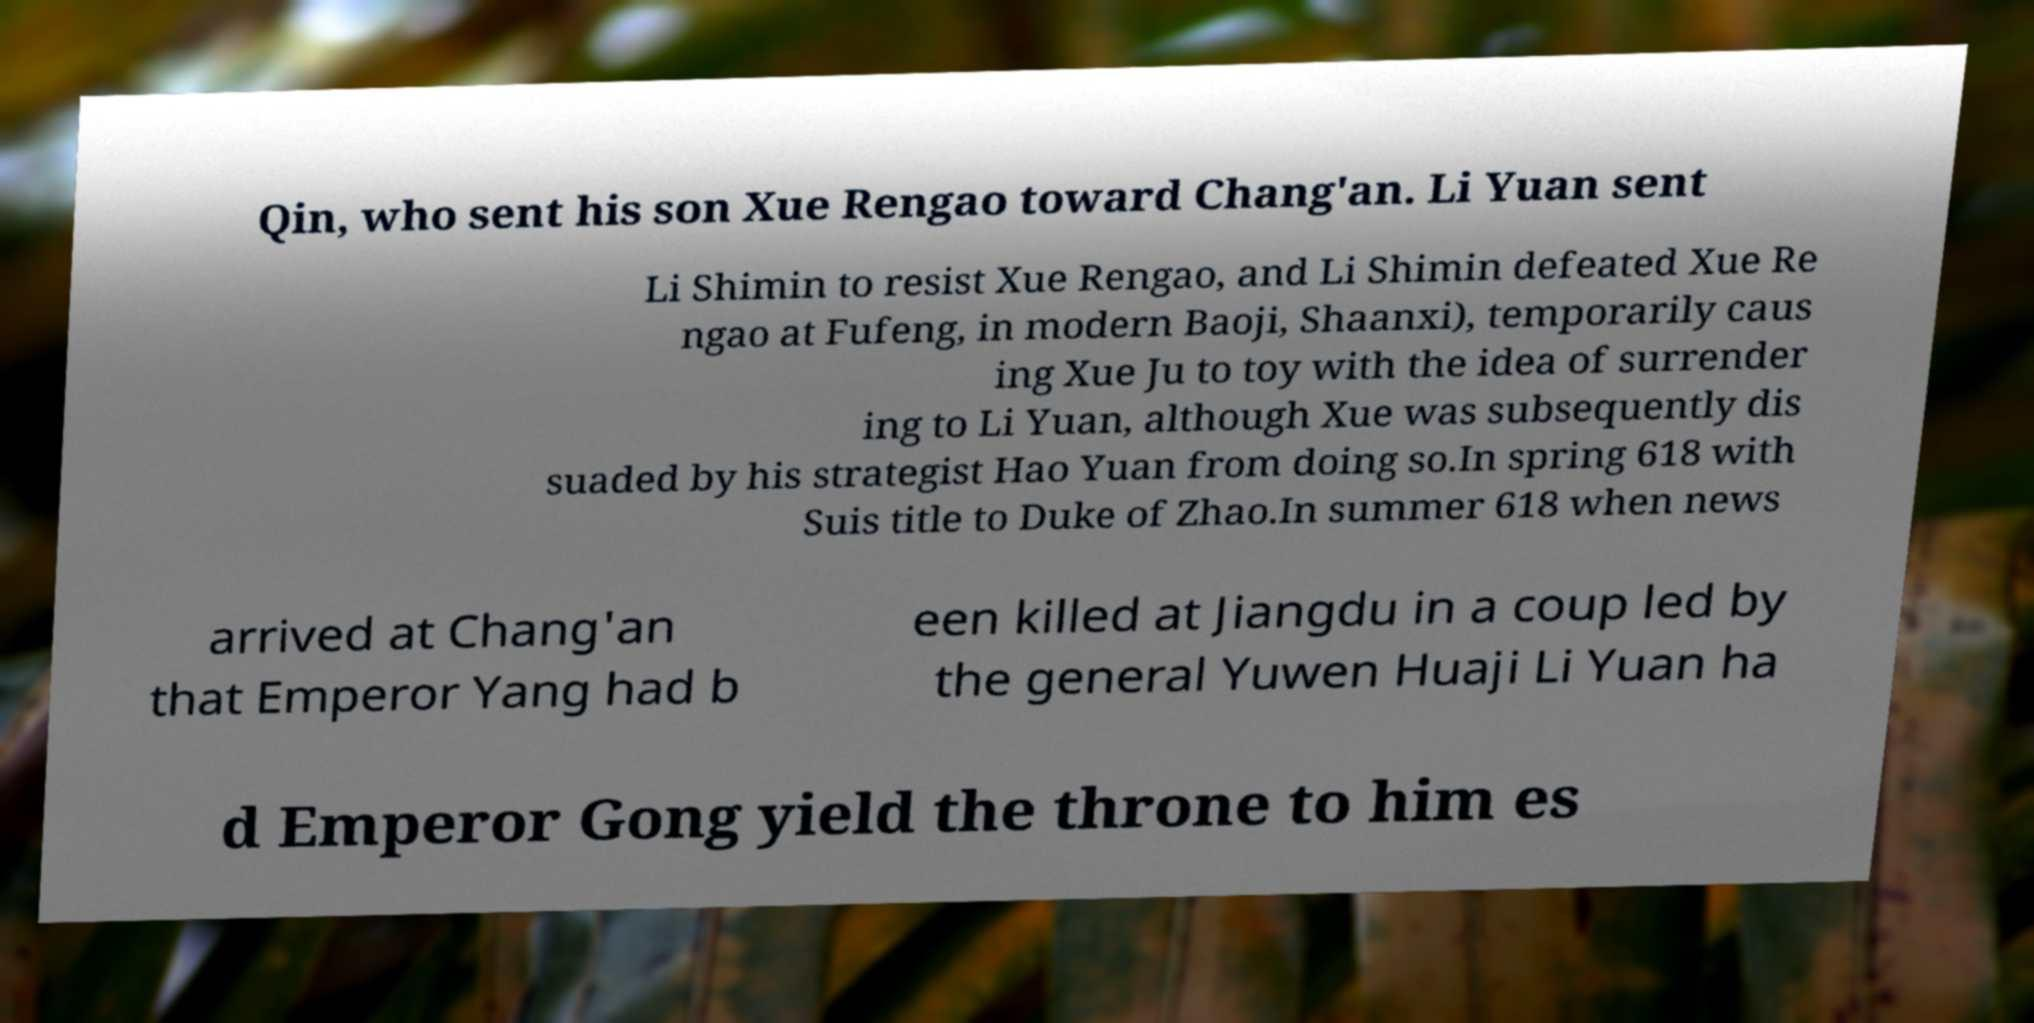Can you accurately transcribe the text from the provided image for me? Qin, who sent his son Xue Rengao toward Chang'an. Li Yuan sent Li Shimin to resist Xue Rengao, and Li Shimin defeated Xue Re ngao at Fufeng, in modern Baoji, Shaanxi), temporarily caus ing Xue Ju to toy with the idea of surrender ing to Li Yuan, although Xue was subsequently dis suaded by his strategist Hao Yuan from doing so.In spring 618 with Suis title to Duke of Zhao.In summer 618 when news arrived at Chang'an that Emperor Yang had b een killed at Jiangdu in a coup led by the general Yuwen Huaji Li Yuan ha d Emperor Gong yield the throne to him es 